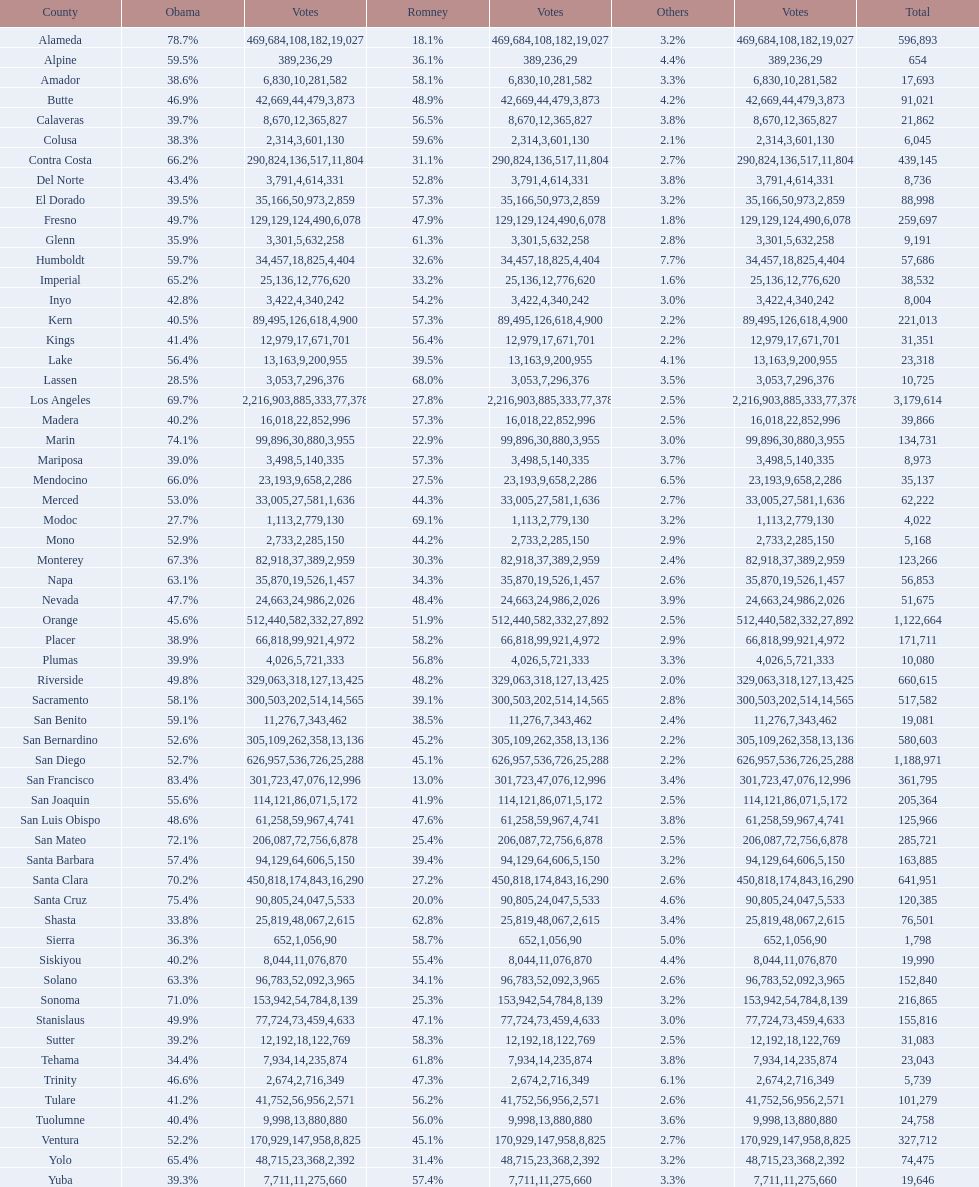What is the vote count for obama in del norte and el dorado counties? 38957. Would you mind parsing the complete table? {'header': ['County', 'Obama', 'Votes', 'Romney', 'Votes', 'Others', 'Votes', 'Total'], 'rows': [['Alameda', '78.7%', '469,684', '18.1%', '108,182', '3.2%', '19,027', '596,893'], ['Alpine', '59.5%', '389', '36.1%', '236', '4.4%', '29', '654'], ['Amador', '38.6%', '6,830', '58.1%', '10,281', '3.3%', '582', '17,693'], ['Butte', '46.9%', '42,669', '48.9%', '44,479', '4.2%', '3,873', '91,021'], ['Calaveras', '39.7%', '8,670', '56.5%', '12,365', '3.8%', '827', '21,862'], ['Colusa', '38.3%', '2,314', '59.6%', '3,601', '2.1%', '130', '6,045'], ['Contra Costa', '66.2%', '290,824', '31.1%', '136,517', '2.7%', '11,804', '439,145'], ['Del Norte', '43.4%', '3,791', '52.8%', '4,614', '3.8%', '331', '8,736'], ['El Dorado', '39.5%', '35,166', '57.3%', '50,973', '3.2%', '2,859', '88,998'], ['Fresno', '49.7%', '129,129', '47.9%', '124,490', '1.8%', '6,078', '259,697'], ['Glenn', '35.9%', '3,301', '61.3%', '5,632', '2.8%', '258', '9,191'], ['Humboldt', '59.7%', '34,457', '32.6%', '18,825', '7.7%', '4,404', '57,686'], ['Imperial', '65.2%', '25,136', '33.2%', '12,776', '1.6%', '620', '38,532'], ['Inyo', '42.8%', '3,422', '54.2%', '4,340', '3.0%', '242', '8,004'], ['Kern', '40.5%', '89,495', '57.3%', '126,618', '2.2%', '4,900', '221,013'], ['Kings', '41.4%', '12,979', '56.4%', '17,671', '2.2%', '701', '31,351'], ['Lake', '56.4%', '13,163', '39.5%', '9,200', '4.1%', '955', '23,318'], ['Lassen', '28.5%', '3,053', '68.0%', '7,296', '3.5%', '376', '10,725'], ['Los Angeles', '69.7%', '2,216,903', '27.8%', '885,333', '2.5%', '77,378', '3,179,614'], ['Madera', '40.2%', '16,018', '57.3%', '22,852', '2.5%', '996', '39,866'], ['Marin', '74.1%', '99,896', '22.9%', '30,880', '3.0%', '3,955', '134,731'], ['Mariposa', '39.0%', '3,498', '57.3%', '5,140', '3.7%', '335', '8,973'], ['Mendocino', '66.0%', '23,193', '27.5%', '9,658', '6.5%', '2,286', '35,137'], ['Merced', '53.0%', '33,005', '44.3%', '27,581', '2.7%', '1,636', '62,222'], ['Modoc', '27.7%', '1,113', '69.1%', '2,779', '3.2%', '130', '4,022'], ['Mono', '52.9%', '2,733', '44.2%', '2,285', '2.9%', '150', '5,168'], ['Monterey', '67.3%', '82,918', '30.3%', '37,389', '2.4%', '2,959', '123,266'], ['Napa', '63.1%', '35,870', '34.3%', '19,526', '2.6%', '1,457', '56,853'], ['Nevada', '47.7%', '24,663', '48.4%', '24,986', '3.9%', '2,026', '51,675'], ['Orange', '45.6%', '512,440', '51.9%', '582,332', '2.5%', '27,892', '1,122,664'], ['Placer', '38.9%', '66,818', '58.2%', '99,921', '2.9%', '4,972', '171,711'], ['Plumas', '39.9%', '4,026', '56.8%', '5,721', '3.3%', '333', '10,080'], ['Riverside', '49.8%', '329,063', '48.2%', '318,127', '2.0%', '13,425', '660,615'], ['Sacramento', '58.1%', '300,503', '39.1%', '202,514', '2.8%', '14,565', '517,582'], ['San Benito', '59.1%', '11,276', '38.5%', '7,343', '2.4%', '462', '19,081'], ['San Bernardino', '52.6%', '305,109', '45.2%', '262,358', '2.2%', '13,136', '580,603'], ['San Diego', '52.7%', '626,957', '45.1%', '536,726', '2.2%', '25,288', '1,188,971'], ['San Francisco', '83.4%', '301,723', '13.0%', '47,076', '3.4%', '12,996', '361,795'], ['San Joaquin', '55.6%', '114,121', '41.9%', '86,071', '2.5%', '5,172', '205,364'], ['San Luis Obispo', '48.6%', '61,258', '47.6%', '59,967', '3.8%', '4,741', '125,966'], ['San Mateo', '72.1%', '206,087', '25.4%', '72,756', '2.5%', '6,878', '285,721'], ['Santa Barbara', '57.4%', '94,129', '39.4%', '64,606', '3.2%', '5,150', '163,885'], ['Santa Clara', '70.2%', '450,818', '27.2%', '174,843', '2.6%', '16,290', '641,951'], ['Santa Cruz', '75.4%', '90,805', '20.0%', '24,047', '4.6%', '5,533', '120,385'], ['Shasta', '33.8%', '25,819', '62.8%', '48,067', '3.4%', '2,615', '76,501'], ['Sierra', '36.3%', '652', '58.7%', '1,056', '5.0%', '90', '1,798'], ['Siskiyou', '40.2%', '8,044', '55.4%', '11,076', '4.4%', '870', '19,990'], ['Solano', '63.3%', '96,783', '34.1%', '52,092', '2.6%', '3,965', '152,840'], ['Sonoma', '71.0%', '153,942', '25.3%', '54,784', '3.2%', '8,139', '216,865'], ['Stanislaus', '49.9%', '77,724', '47.1%', '73,459', '3.0%', '4,633', '155,816'], ['Sutter', '39.2%', '12,192', '58.3%', '18,122', '2.5%', '769', '31,083'], ['Tehama', '34.4%', '7,934', '61.8%', '14,235', '3.8%', '874', '23,043'], ['Trinity', '46.6%', '2,674', '47.3%', '2,716', '6.1%', '349', '5,739'], ['Tulare', '41.2%', '41,752', '56.2%', '56,956', '2.6%', '2,571', '101,279'], ['Tuolumne', '40.4%', '9,998', '56.0%', '13,880', '3.6%', '880', '24,758'], ['Ventura', '52.2%', '170,929', '45.1%', '147,958', '2.7%', '8,825', '327,712'], ['Yolo', '65.4%', '48,715', '31.4%', '23,368', '3.2%', '2,392', '74,475'], ['Yuba', '39.3%', '7,711', '57.4%', '11,275', '3.3%', '660', '19,646']]} 